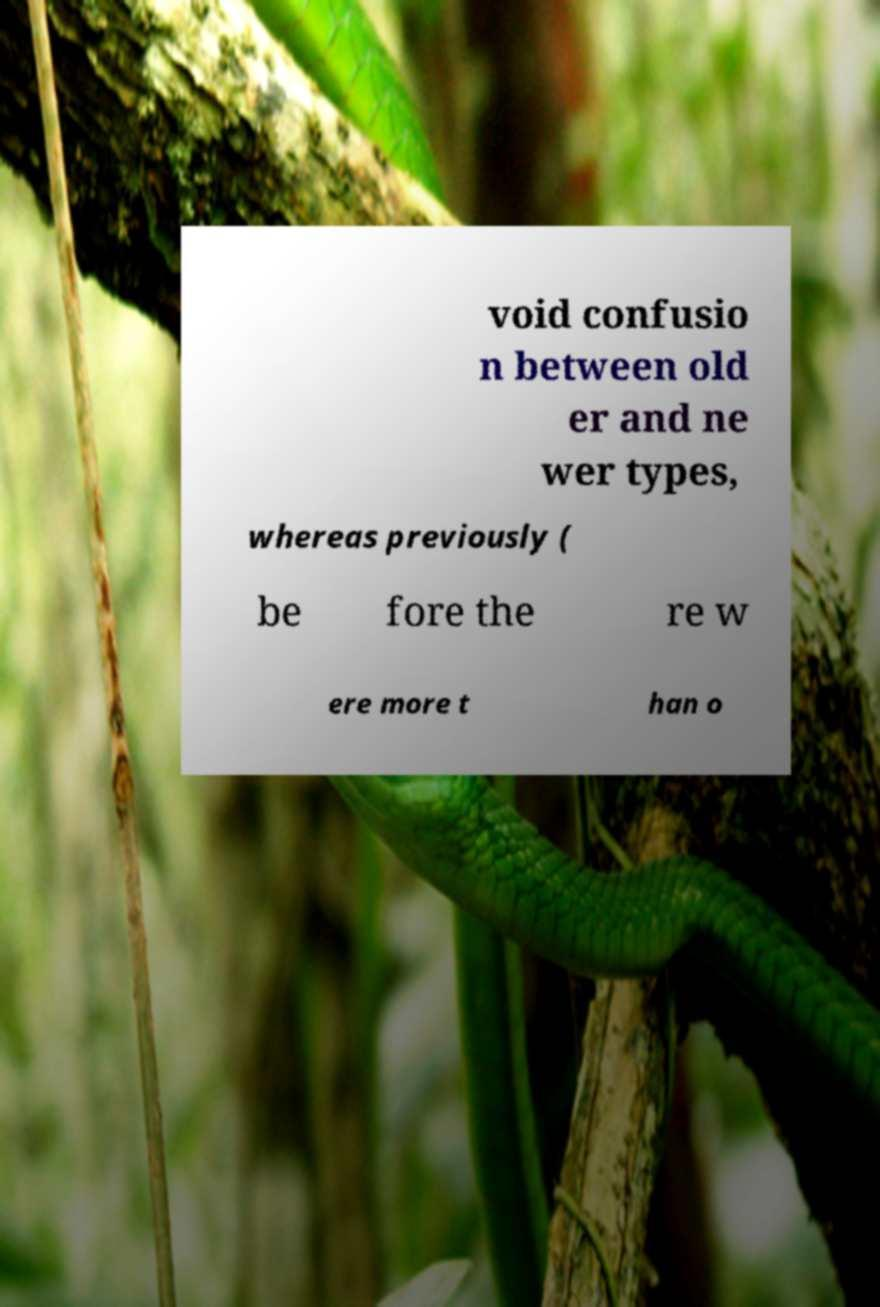Could you assist in decoding the text presented in this image and type it out clearly? void confusio n between old er and ne wer types, whereas previously ( be fore the re w ere more t han o 